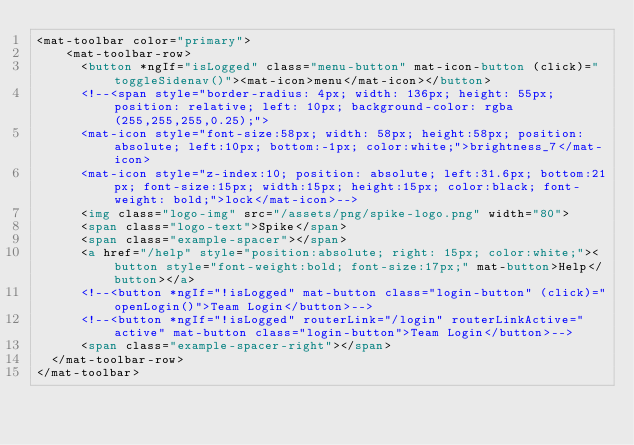Convert code to text. <code><loc_0><loc_0><loc_500><loc_500><_HTML_><mat-toolbar color="primary">
    <mat-toolbar-row>
      <button *ngIf="isLogged" class="menu-button" mat-icon-button (click)="toggleSidenav()"><mat-icon>menu</mat-icon></button>
      <!--<span style="border-radius: 4px; width: 136px; height: 55px; position: relative; left: 10px; background-color: rgba(255,255,255,0.25);">
      <mat-icon style="font-size:58px; width: 58px; height:58px; position:absolute; left:10px; bottom:-1px; color:white;">brightness_7</mat-icon>
      <mat-icon style="z-index:10; position: absolute; left:31.6px; bottom:21px; font-size:15px; width:15px; height:15px; color:black; font-weight: bold;">lock</mat-icon>-->
      <img class="logo-img" src="/assets/png/spike-logo.png" width="80">
      <span class="logo-text">Spike</span>
      <span class="example-spacer"></span>
      <a href="/help" style="position:absolute; right: 15px; color:white;"><button style="font-weight:bold; font-size:17px;" mat-button>Help</button></a>
      <!--<button *ngIf="!isLogged" mat-button class="login-button" (click)="openLogin()">Team Login</button>-->
      <!--<button *ngIf="!isLogged" routerLink="/login" routerLinkActive="active" mat-button class="login-button">Team Login</button>-->
      <span class="example-spacer-right"></span>
  </mat-toolbar-row>
</mat-toolbar>
</code> 